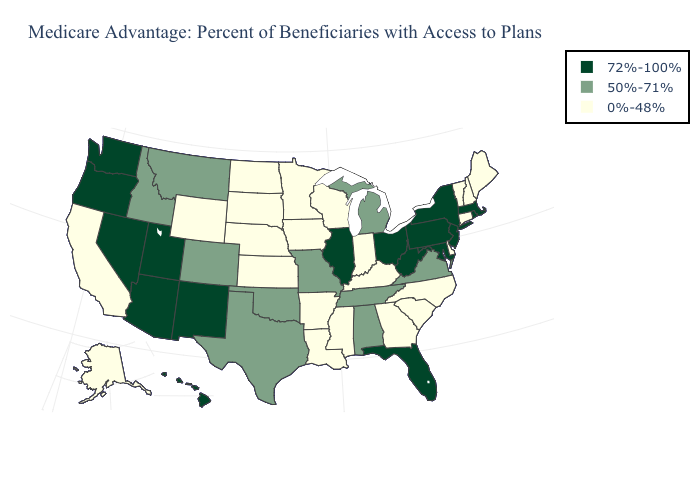Name the states that have a value in the range 0%-48%?
Give a very brief answer. Alaska, Arkansas, California, Connecticut, Delaware, Georgia, Iowa, Indiana, Kansas, Kentucky, Louisiana, Maine, Minnesota, Mississippi, North Carolina, North Dakota, Nebraska, New Hampshire, South Carolina, South Dakota, Vermont, Wisconsin, Wyoming. Name the states that have a value in the range 72%-100%?
Give a very brief answer. Arizona, Florida, Hawaii, Illinois, Massachusetts, Maryland, New Jersey, New Mexico, Nevada, New York, Ohio, Oregon, Pennsylvania, Rhode Island, Utah, Washington, West Virginia. Which states hav the highest value in the South?
Keep it brief. Florida, Maryland, West Virginia. Does Pennsylvania have the highest value in the USA?
Concise answer only. Yes. What is the highest value in states that border Michigan?
Concise answer only. 72%-100%. Name the states that have a value in the range 50%-71%?
Give a very brief answer. Alabama, Colorado, Idaho, Michigan, Missouri, Montana, Oklahoma, Tennessee, Texas, Virginia. Among the states that border Florida , does Alabama have the lowest value?
Short answer required. No. Does the map have missing data?
Concise answer only. No. Name the states that have a value in the range 0%-48%?
Be succinct. Alaska, Arkansas, California, Connecticut, Delaware, Georgia, Iowa, Indiana, Kansas, Kentucky, Louisiana, Maine, Minnesota, Mississippi, North Carolina, North Dakota, Nebraska, New Hampshire, South Carolina, South Dakota, Vermont, Wisconsin, Wyoming. How many symbols are there in the legend?
Quick response, please. 3. Name the states that have a value in the range 72%-100%?
Concise answer only. Arizona, Florida, Hawaii, Illinois, Massachusetts, Maryland, New Jersey, New Mexico, Nevada, New York, Ohio, Oregon, Pennsylvania, Rhode Island, Utah, Washington, West Virginia. Name the states that have a value in the range 50%-71%?
Answer briefly. Alabama, Colorado, Idaho, Michigan, Missouri, Montana, Oklahoma, Tennessee, Texas, Virginia. Does Nebraska have a higher value than Rhode Island?
Write a very short answer. No. Name the states that have a value in the range 72%-100%?
Be succinct. Arizona, Florida, Hawaii, Illinois, Massachusetts, Maryland, New Jersey, New Mexico, Nevada, New York, Ohio, Oregon, Pennsylvania, Rhode Island, Utah, Washington, West Virginia. Does New Mexico have the highest value in the USA?
Concise answer only. Yes. 